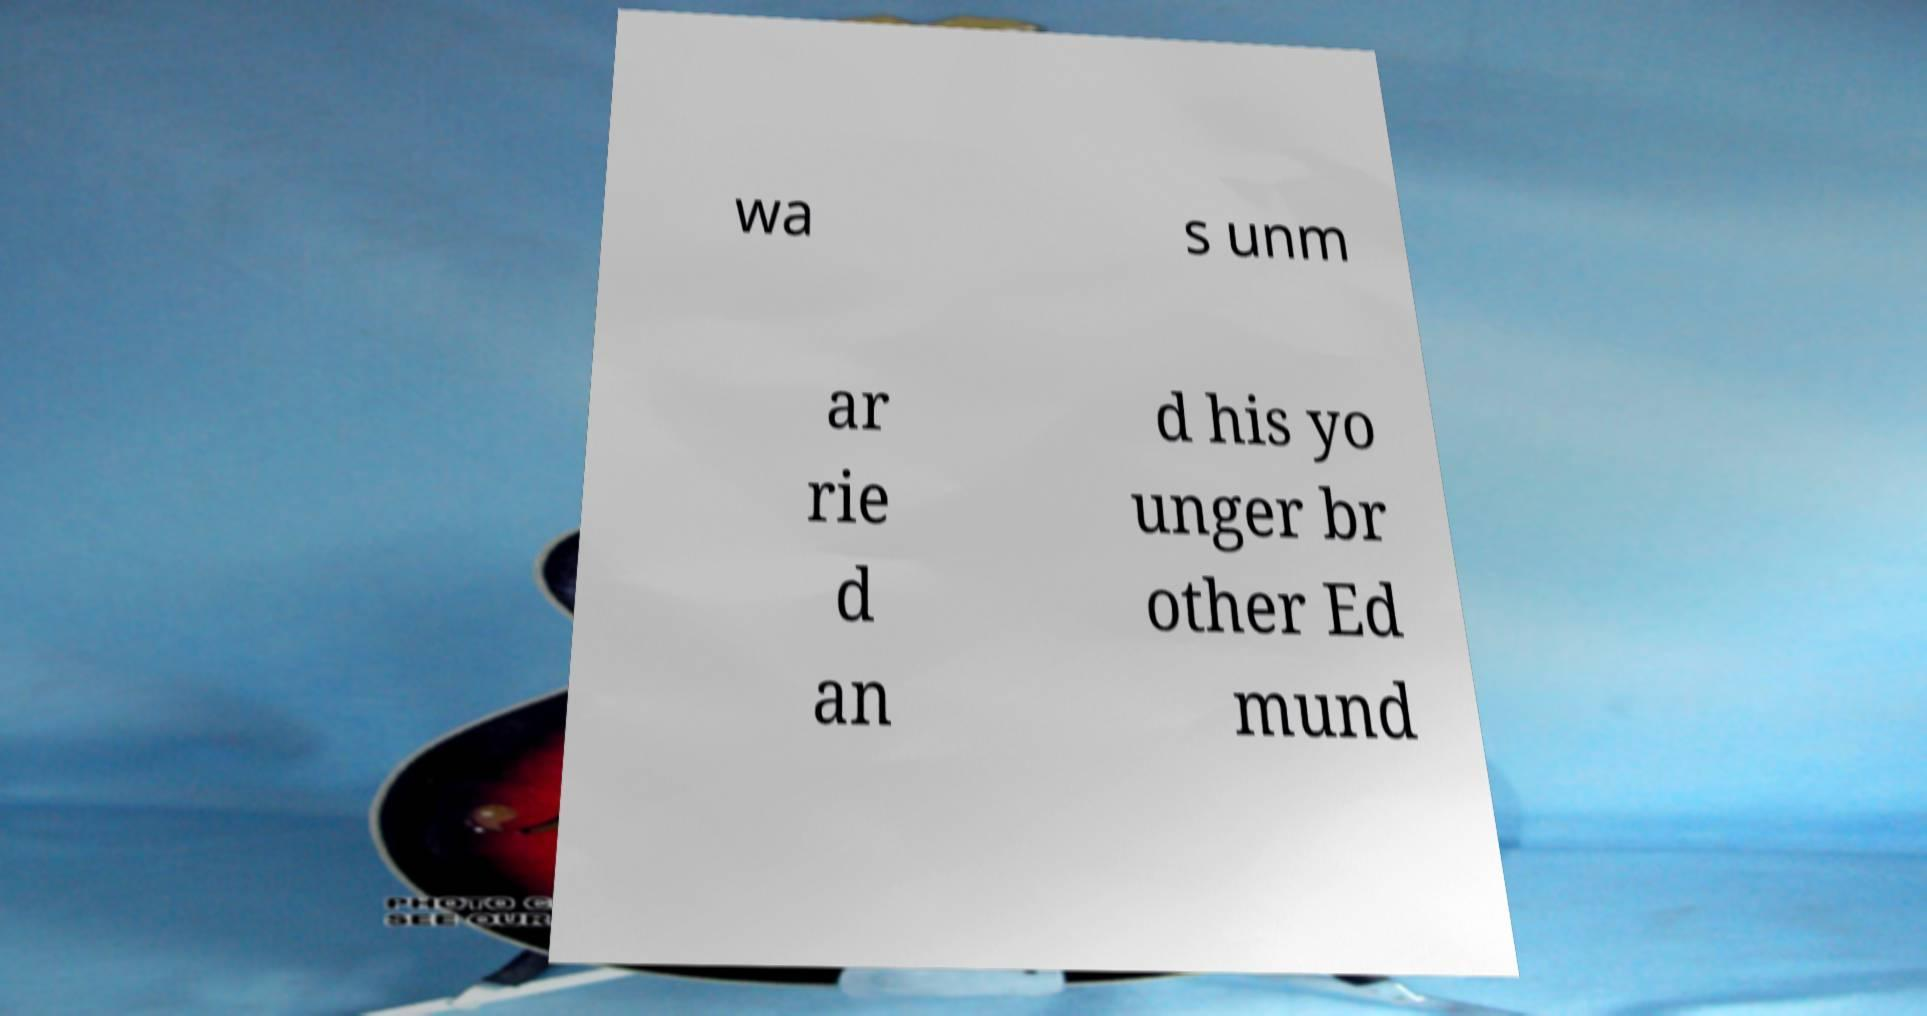I need the written content from this picture converted into text. Can you do that? wa s unm ar rie d an d his yo unger br other Ed mund 